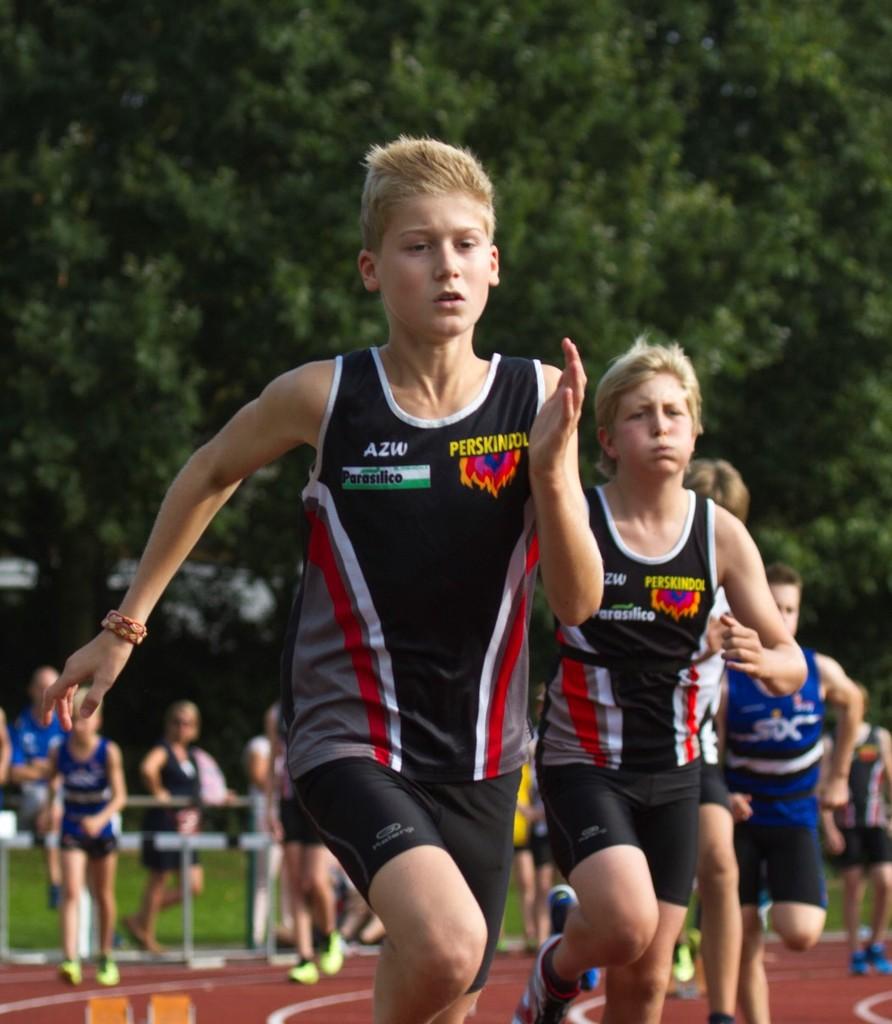What are the three initials on this boy's shirt?
Your response must be concise. Azw. 